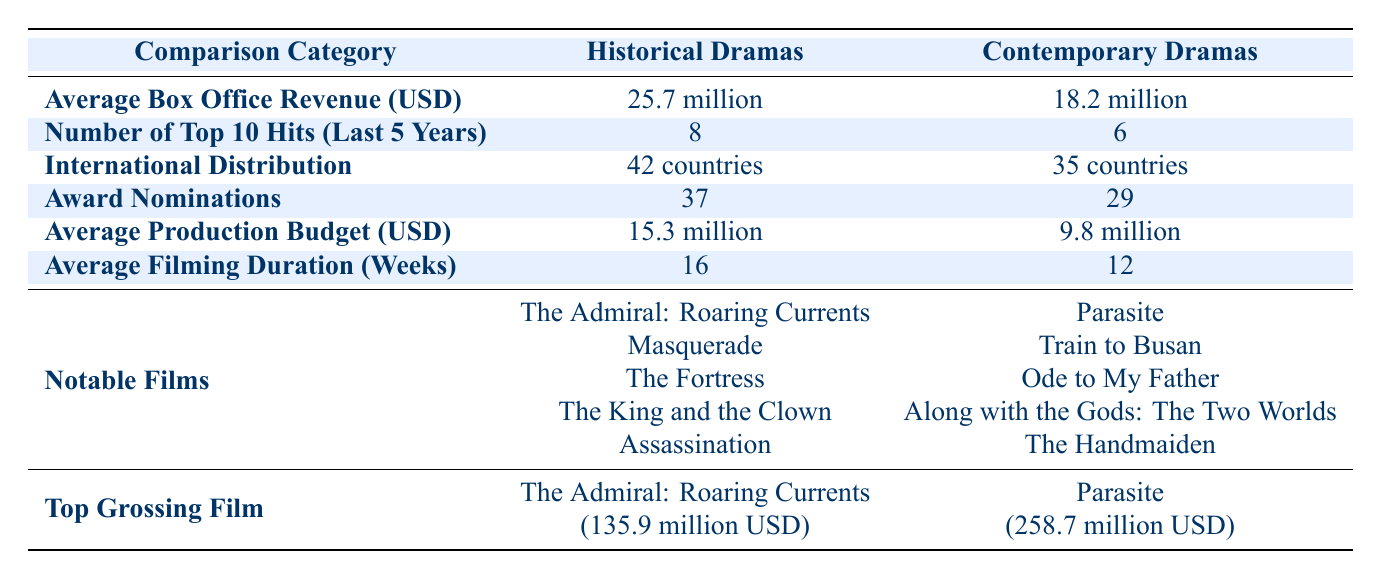What is the average box office revenue for historical dramas? The table shows that the average box office revenue for historical dramas is 25.7 million USD.
Answer: 25.7 million USD How many top 10 hits did contemporary dramas have in the last 5 years? According to the table, contemporary dramas had 6 top 10 hits in the last 5 years.
Answer: 6 True or False: Historical dramas have more award nominations than contemporary dramas. The table indicates that historical dramas have 37 award nominations while contemporary dramas have 29, confirming that historical dramas have more nominations.
Answer: True What is the difference in the average production budget between historical and contemporary dramas? The average production budget for historical dramas is 15.3 million USD and for contemporary dramas is 9.8 million USD. The difference is calculated as 15.3 - 9.8 = 5.5 million USD.
Answer: 5.5 million USD Which genre has a greater average filming duration? According to the table, historical dramas have an average filming duration of 16 weeks, while contemporary dramas have 12 weeks. Therefore, historical dramas have a greater duration.
Answer: Historical dramas How many countries distribute historical dramas internationally? The table states that historical dramas are distributed in 42 countries.
Answer: 42 countries What is the total number of top 10 hits for both historical and contemporary dramas combined? The table lists 8 top 10 hits for historical dramas and 6 for contemporary dramas. Adding these together gives 8 + 6 = 14 top 10 hits.
Answer: 14 True or False: The top-grossing film among historical dramas exceeds 200 million USD. The top-grossing historical drama, "The Admiral: Roaring Currents," made 135.9 million USD, which does not exceed 200 million USD, making the statement false.
Answer: False What is the box office revenue for the top-grossing contemporary drama? The table shows that the top-grossing contemporary drama, "Parasite," earned 258.7 million USD at the box office.
Answer: 258.7 million USD 